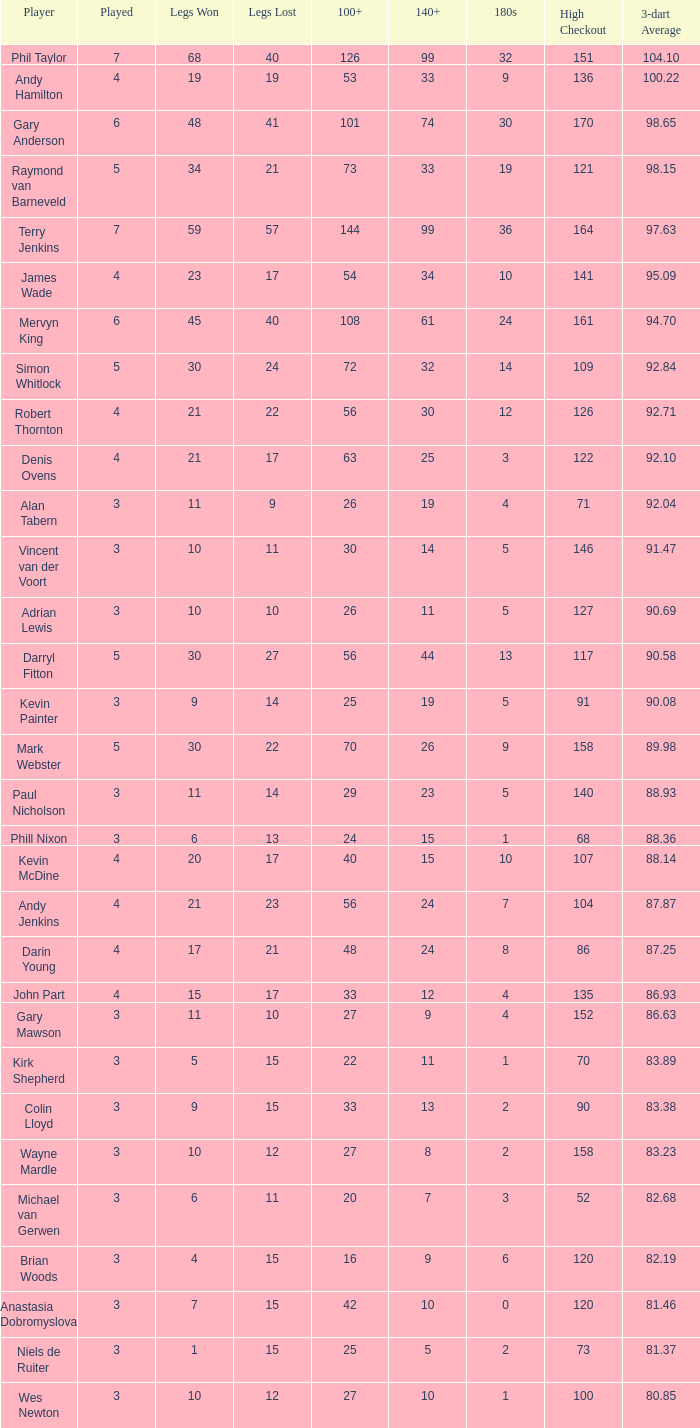What is the most legs lost of all? 57.0. 